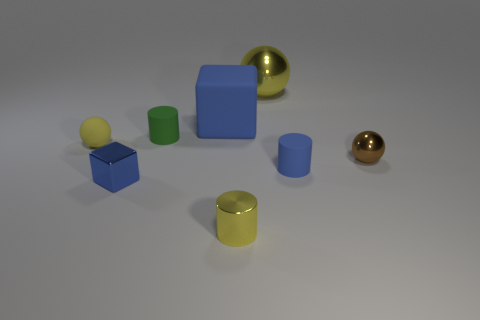Subtract 1 spheres. How many spheres are left? 2 Add 1 big balls. How many objects exist? 9 Subtract all cylinders. How many objects are left? 5 Add 4 small metal blocks. How many small metal blocks exist? 5 Subtract 0 yellow cubes. How many objects are left? 8 Subtract all small cyan shiny cylinders. Subtract all large rubber blocks. How many objects are left? 7 Add 8 yellow metal cylinders. How many yellow metal cylinders are left? 9 